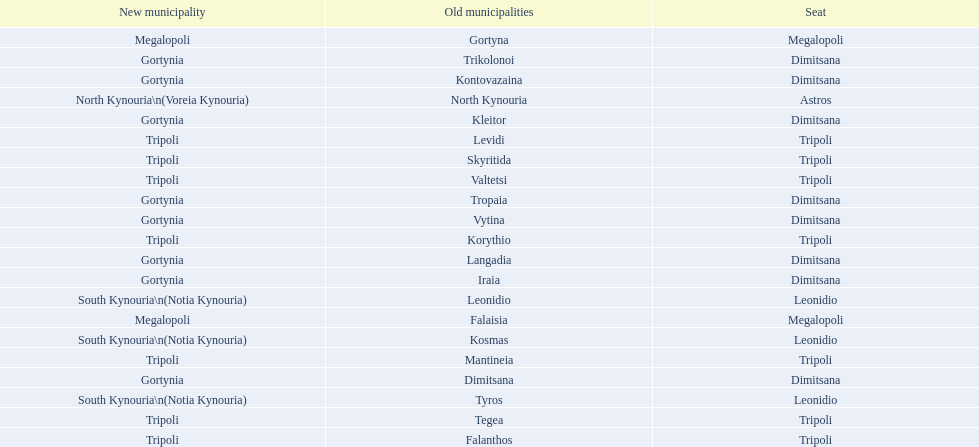How many old municipalities were in tripoli? 8. 